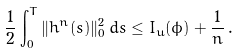<formula> <loc_0><loc_0><loc_500><loc_500>\frac { 1 } { 2 } \int _ { 0 } ^ { T } \| h ^ { n } ( s ) \| _ { 0 } ^ { 2 } \, d s \leq I _ { u } ( \phi ) + \frac { 1 } { n } \, .</formula> 